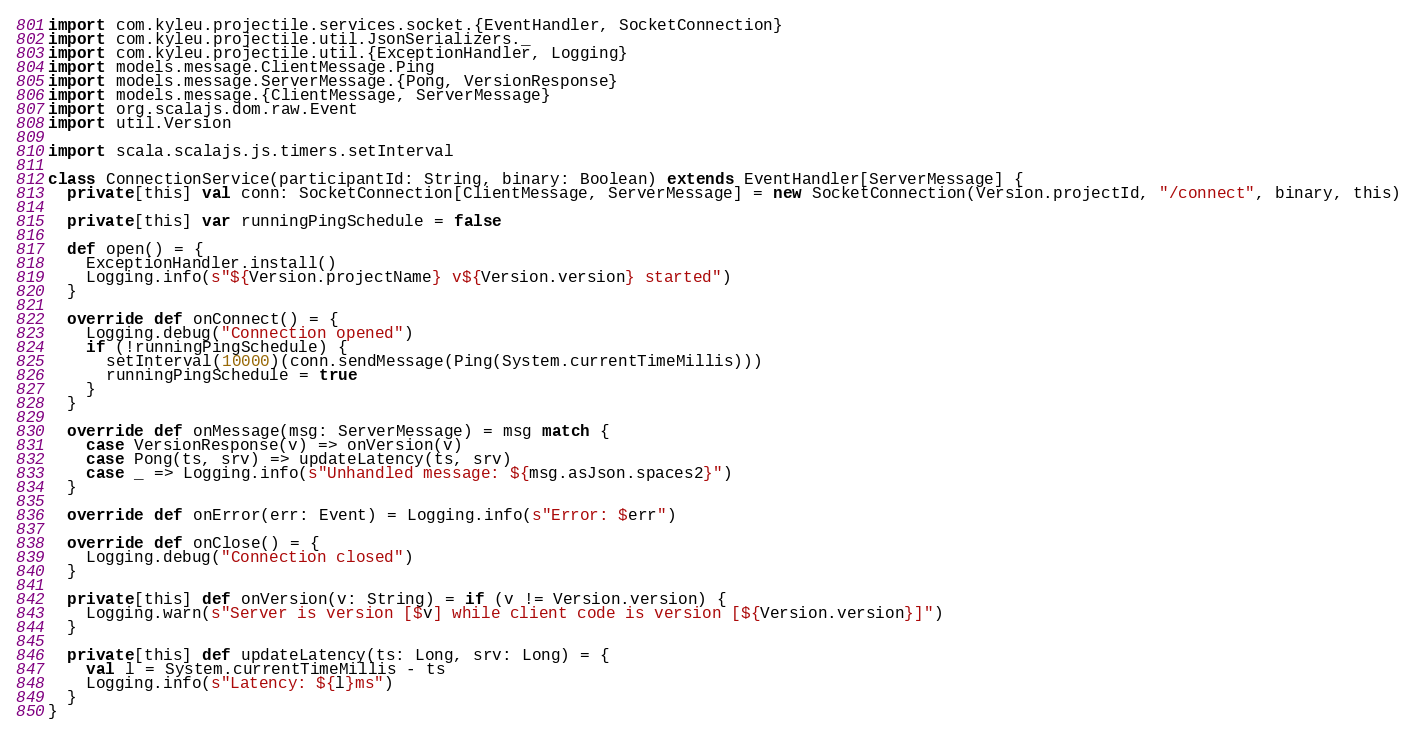<code> <loc_0><loc_0><loc_500><loc_500><_Scala_>import com.kyleu.projectile.services.socket.{EventHandler, SocketConnection}
import com.kyleu.projectile.util.JsonSerializers._
import com.kyleu.projectile.util.{ExceptionHandler, Logging}
import models.message.ClientMessage.Ping
import models.message.ServerMessage.{Pong, VersionResponse}
import models.message.{ClientMessage, ServerMessage}
import org.scalajs.dom.raw.Event
import util.Version

import scala.scalajs.js.timers.setInterval

class ConnectionService(participantId: String, binary: Boolean) extends EventHandler[ServerMessage] {
  private[this] val conn: SocketConnection[ClientMessage, ServerMessage] = new SocketConnection(Version.projectId, "/connect", binary, this)

  private[this] var runningPingSchedule = false

  def open() = {
    ExceptionHandler.install()
    Logging.info(s"${Version.projectName} v${Version.version} started")
  }

  override def onConnect() = {
    Logging.debug("Connection opened")
    if (!runningPingSchedule) {
      setInterval(10000)(conn.sendMessage(Ping(System.currentTimeMillis)))
      runningPingSchedule = true
    }
  }

  override def onMessage(msg: ServerMessage) = msg match {
    case VersionResponse(v) => onVersion(v)
    case Pong(ts, srv) => updateLatency(ts, srv)
    case _ => Logging.info(s"Unhandled message: ${msg.asJson.spaces2}")
  }

  override def onError(err: Event) = Logging.info(s"Error: $err")

  override def onClose() = {
    Logging.debug("Connection closed")
  }

  private[this] def onVersion(v: String) = if (v != Version.version) {
    Logging.warn(s"Server is version [$v] while client code is version [${Version.version}]")
  }

  private[this] def updateLatency(ts: Long, srv: Long) = {
    val l = System.currentTimeMillis - ts
    Logging.info(s"Latency: ${l}ms")
  }
}
</code> 